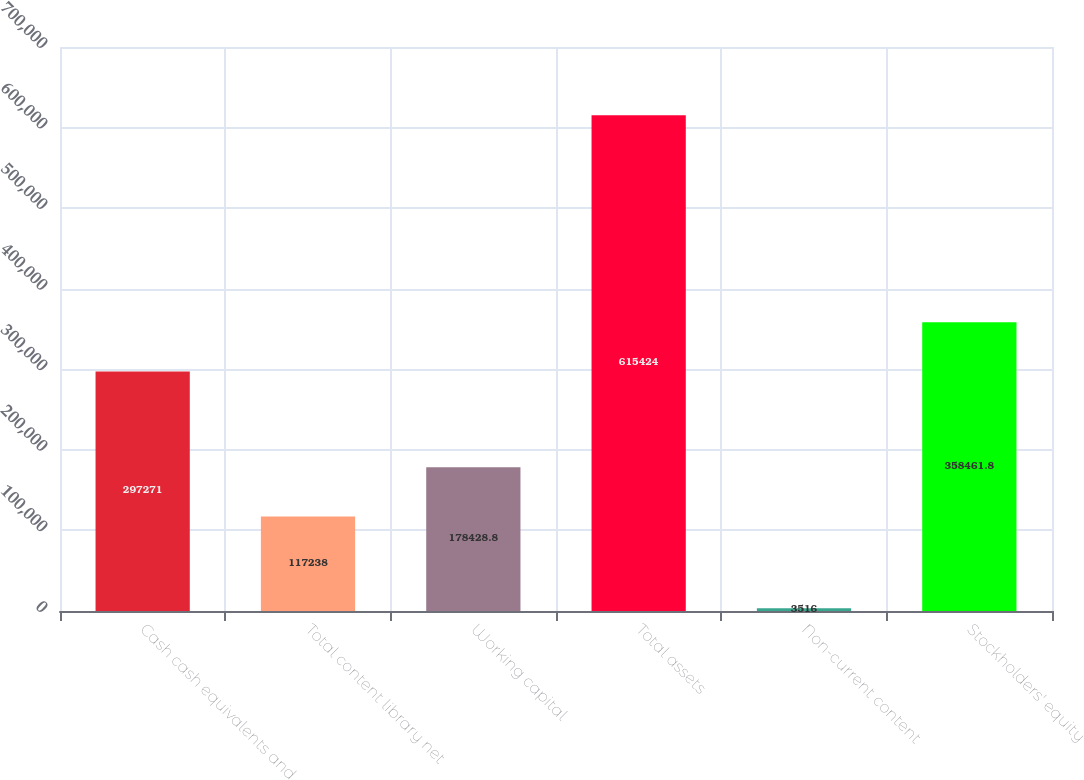Convert chart to OTSL. <chart><loc_0><loc_0><loc_500><loc_500><bar_chart><fcel>Cash cash equivalents and<fcel>Total content library net<fcel>Working capital<fcel>Total assets<fcel>Non-current content<fcel>Stockholders' equity<nl><fcel>297271<fcel>117238<fcel>178429<fcel>615424<fcel>3516<fcel>358462<nl></chart> 